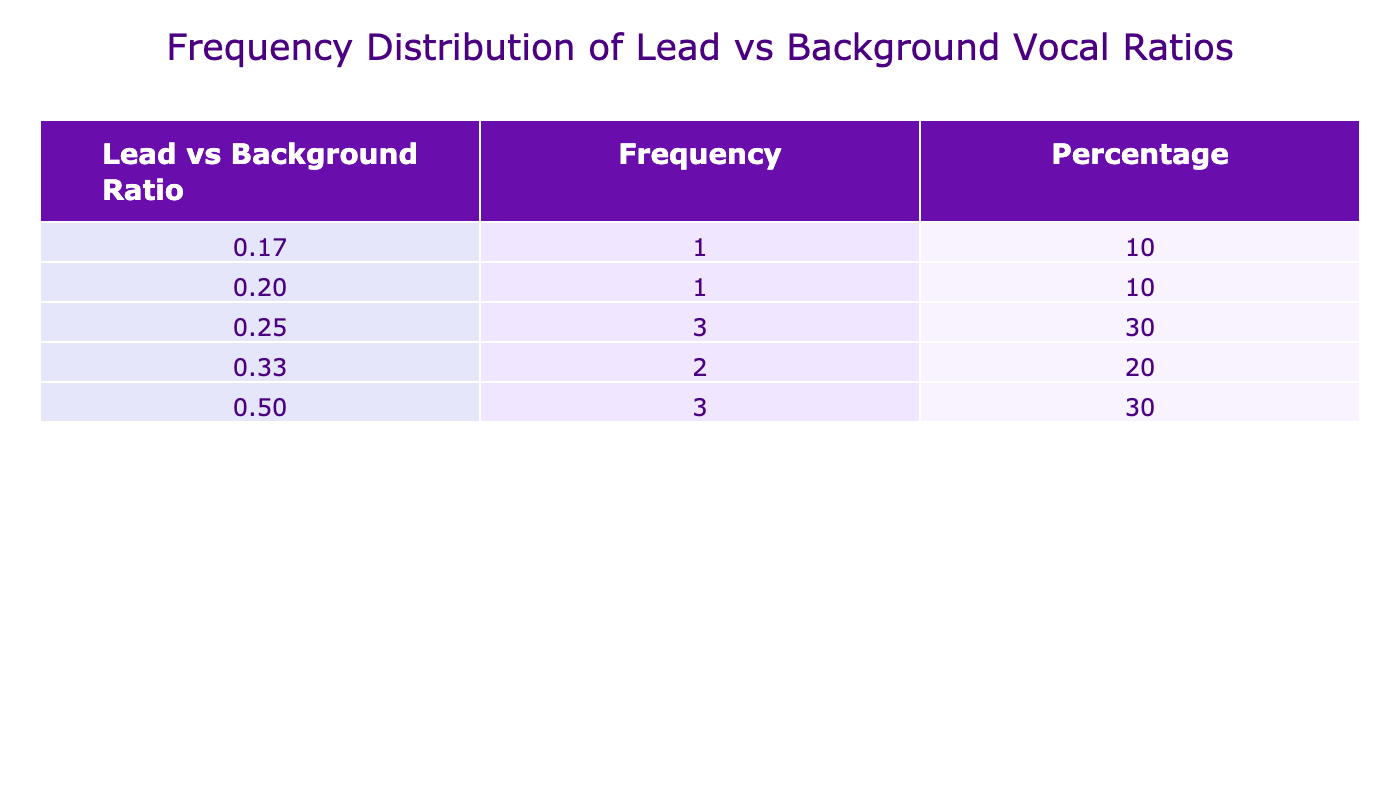What is the most common lead vs background ratio? The table shows the frequency of each lead vs background ratio. The highest frequency value is for the ratio of 0.25, which appears in three albums: "Thriller", "Future Nostalgia", and "Lemonade".
Answer: 0.25 How many albums have a lead vs background ratio of 0.50? Referring to the table, there are three albums with a lead vs background ratio of 0.50: "Back in Black", "Nevermind", and "Born to Run".
Answer: 3 What is the average lead vs background ratio across all albums? To find the average, we sum the different ratios: 0.33 (1 album) + 0.25 (3 albums) + 0.50 (3 albums) + 0.20 (1 album) + 0.17 (1 album) = 1.75, then divide by 10 (the number of albums): 1.75 / 10 = 0.175.
Answer: 0.175 Are there any albums with a lead vs background ratio greater than 0.33? By checking the table, we can see that no albums have a ratio greater than 0.33. The maximum ratio listed is 0.50.
Answer: No What percentage of albums have a lead vs background ratio of 0.25? Looking at the frequency for the ratio of 0.25, it appears in 3 albums. The total number of albums is 10, so the percentage is (3/10) * 100 = 30%.
Answer: 30% How does the frequency distribution change between ratios of 0.20 and 0.50? The frequency for ratio 0.20 is 1 album, while for ratio 0.50, it is 3 albums. This indicates that more albums favor a 0.50 ratio compared to a 0.20 ratio.
Answer: More albums favor 0.50 than 0.20 